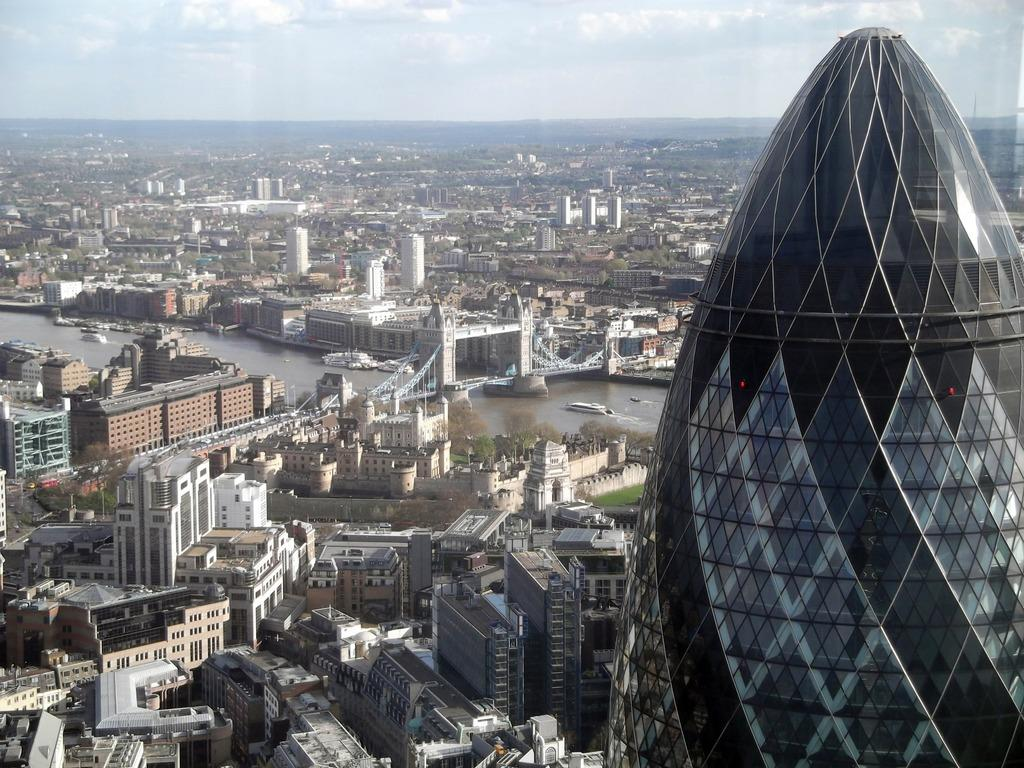What can be seen at the bottom of the image? There are buildings, trees, boats, water, and a bridge at the bottom of the image. What is located on the right side of the image? There is a tower on the right side of the image. What is visible at the top of the image? The sky is visible at the top of the image. What can be observed in the sky? There are clouds in the sky. Can you see a kiss happening between the buildings in the image? There is no kiss present in the image; it features buildings, trees, boats, water, a bridge, a tower, and a sky with clouds. Are there any cobwebs visible on the tower in the image? There is no mention of cobwebs in the image, and the focus is on the tower's presence rather than its details. 